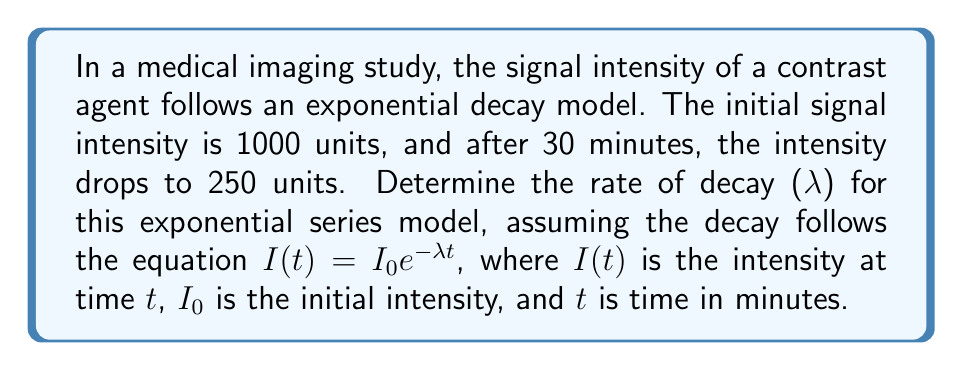Help me with this question. To solve this problem, we'll follow these steps:

1) We know that the exponential decay model follows the equation:
   $I(t) = I_0e^{-λt}$

2) We're given the following information:
   $I_0 = 1000$ (initial intensity)
   $I(30) = 250$ (intensity after 30 minutes)
   $t = 30$ (time in minutes)

3) Let's substitute these values into the equation:
   $250 = 1000e^{-λ(30)}$

4) Divide both sides by 1000:
   $\frac{250}{1000} = e^{-30λ}$
   $0.25 = e^{-30λ}$

5) Take the natural logarithm of both sides:
   $\ln(0.25) = \ln(e^{-30λ})$
   $\ln(0.25) = -30λ$

6) Solve for λ:
   $-30λ = \ln(0.25)$
   $λ = -\frac{\ln(0.25)}{30}$

7) Calculate the final value:
   $λ = -\frac{\ln(0.25)}{30} \approx 0.0462$ per minute

Therefore, the rate of decay (λ) is approximately 0.0462 per minute.
Answer: $λ \approx 0.0462$ per minute 